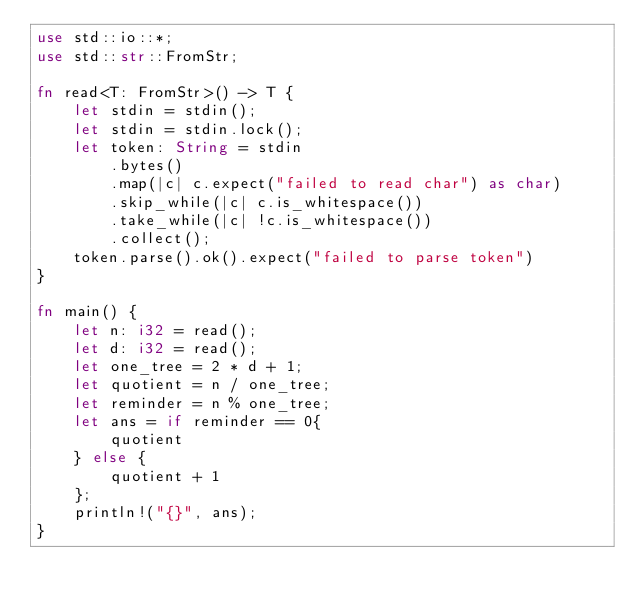Convert code to text. <code><loc_0><loc_0><loc_500><loc_500><_Rust_>use std::io::*;
use std::str::FromStr;

fn read<T: FromStr>() -> T {
    let stdin = stdin();
    let stdin = stdin.lock();
    let token: String = stdin
        .bytes()
        .map(|c| c.expect("failed to read char") as char)
        .skip_while(|c| c.is_whitespace())
        .take_while(|c| !c.is_whitespace())
        .collect();
    token.parse().ok().expect("failed to parse token")
}

fn main() {
    let n: i32 = read();
    let d: i32 = read();
    let one_tree = 2 * d + 1;
    let quotient = n / one_tree;
    let reminder = n % one_tree;
    let ans = if reminder == 0{
        quotient
    } else {
        quotient + 1
    };
    println!("{}", ans);
}
</code> 